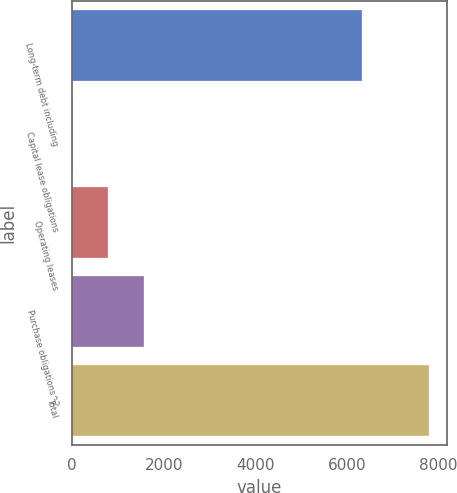<chart> <loc_0><loc_0><loc_500><loc_500><bar_chart><fcel>Long-term debt including<fcel>Capital lease obligations<fcel>Operating leases<fcel>Purchase obligations^2<fcel>Total<nl><fcel>6341.5<fcel>6<fcel>785.28<fcel>1564.56<fcel>7798.8<nl></chart> 